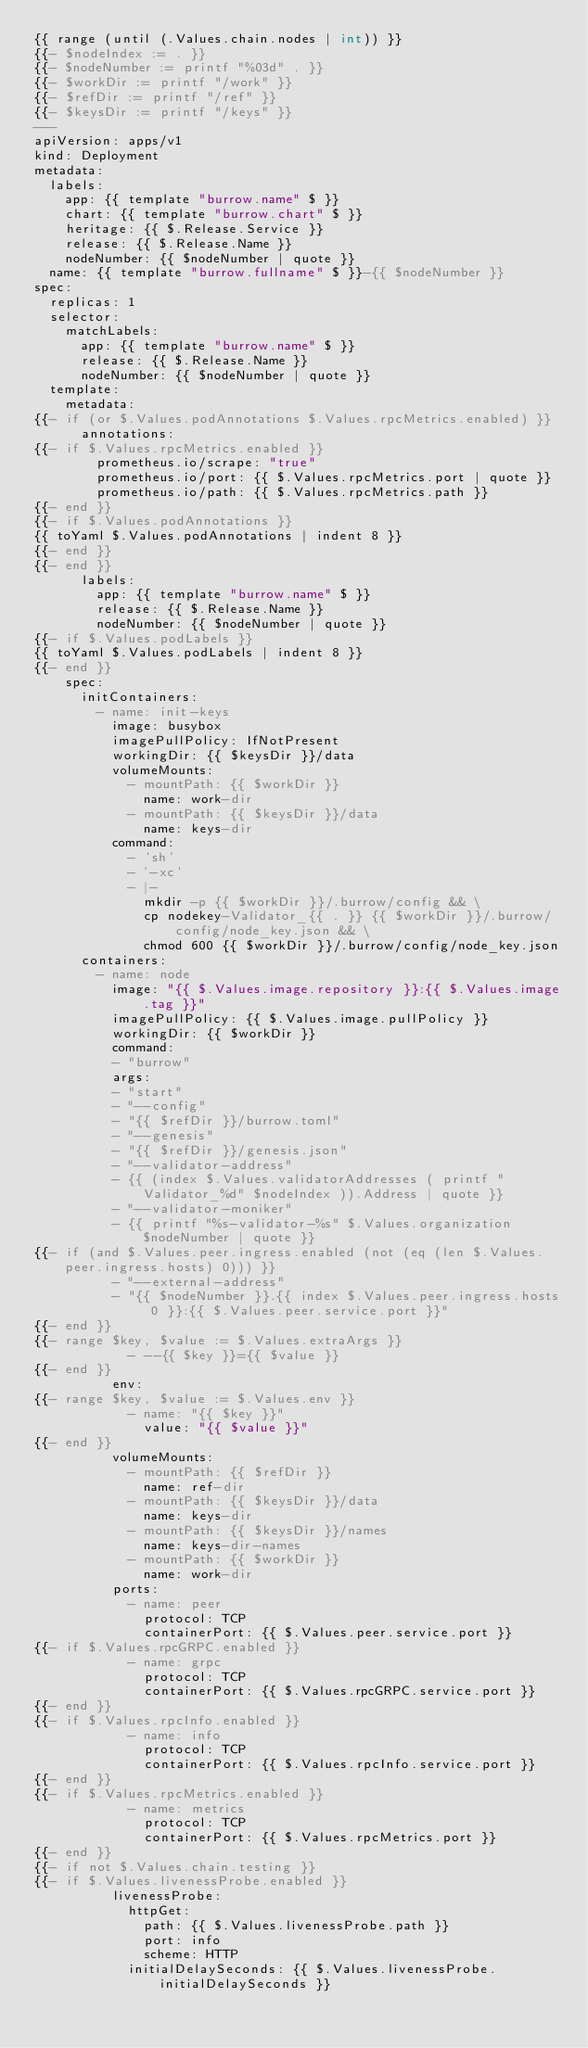<code> <loc_0><loc_0><loc_500><loc_500><_YAML_>{{ range (until (.Values.chain.nodes | int)) }}
{{- $nodeIndex := . }}
{{- $nodeNumber := printf "%03d" . }}
{{- $workDir := printf "/work" }}
{{- $refDir := printf "/ref" }}
{{- $keysDir := printf "/keys" }}
---
apiVersion: apps/v1
kind: Deployment
metadata:
  labels:
    app: {{ template "burrow.name" $ }}
    chart: {{ template "burrow.chart" $ }}
    heritage: {{ $.Release.Service }}
    release: {{ $.Release.Name }}
    nodeNumber: {{ $nodeNumber | quote }}
  name: {{ template "burrow.fullname" $ }}-{{ $nodeNumber }}
spec:
  replicas: 1
  selector:
    matchLabels:
      app: {{ template "burrow.name" $ }}
      release: {{ $.Release.Name }}
      nodeNumber: {{ $nodeNumber | quote }}
  template:
    metadata:
{{- if (or $.Values.podAnnotations $.Values.rpcMetrics.enabled) }}
      annotations:
{{- if $.Values.rpcMetrics.enabled }}
        prometheus.io/scrape: "true"
        prometheus.io/port: {{ $.Values.rpcMetrics.port | quote }}
        prometheus.io/path: {{ $.Values.rpcMetrics.path }}
{{- end }}
{{- if $.Values.podAnnotations }}
{{ toYaml $.Values.podAnnotations | indent 8 }}
{{- end }}
{{- end }}
      labels:
        app: {{ template "burrow.name" $ }}
        release: {{ $.Release.Name }}
        nodeNumber: {{ $nodeNumber | quote }}
{{- if $.Values.podLabels }}
{{ toYaml $.Values.podLabels | indent 8 }}
{{- end }}
    spec:
      initContainers:
        - name: init-keys
          image: busybox
          imagePullPolicy: IfNotPresent
          workingDir: {{ $keysDir }}/data
          volumeMounts:
            - mountPath: {{ $workDir }}
              name: work-dir
            - mountPath: {{ $keysDir }}/data
              name: keys-dir
          command:
            - 'sh'
            - '-xc'
            - |-
              mkdir -p {{ $workDir }}/.burrow/config && \
              cp nodekey-Validator_{{ . }} {{ $workDir }}/.burrow/config/node_key.json && \
              chmod 600 {{ $workDir }}/.burrow/config/node_key.json
      containers:
        - name: node
          image: "{{ $.Values.image.repository }}:{{ $.Values.image.tag }}"
          imagePullPolicy: {{ $.Values.image.pullPolicy }}
          workingDir: {{ $workDir }}
          command:
          - "burrow"
          args:
          - "start"
          - "--config"
          - "{{ $refDir }}/burrow.toml"
          - "--genesis"
          - "{{ $refDir }}/genesis.json"
          - "--validator-address"
          - {{ (index $.Values.validatorAddresses ( printf "Validator_%d" $nodeIndex )).Address | quote }}
          - "--validator-moniker"
          - {{ printf "%s-validator-%s" $.Values.organization $nodeNumber | quote }}
{{- if (and $.Values.peer.ingress.enabled (not (eq (len $.Values.peer.ingress.hosts) 0))) }}
          - "--external-address"
          - "{{ $nodeNumber }}.{{ index $.Values.peer.ingress.hosts 0 }}:{{ $.Values.peer.service.port }}"
{{- end }}
{{- range $key, $value := $.Values.extraArgs }}
            - --{{ $key }}={{ $value }}
{{- end }}
          env:
{{- range $key, $value := $.Values.env }}
            - name: "{{ $key }}"
              value: "{{ $value }}"
{{- end }}
          volumeMounts:
            - mountPath: {{ $refDir }}
              name: ref-dir
            - mountPath: {{ $keysDir }}/data
              name: keys-dir
            - mountPath: {{ $keysDir }}/names
              name: keys-dir-names
            - mountPath: {{ $workDir }}
              name: work-dir
          ports:
            - name: peer
              protocol: TCP
              containerPort: {{ $.Values.peer.service.port }}
{{- if $.Values.rpcGRPC.enabled }}
            - name: grpc
              protocol: TCP
              containerPort: {{ $.Values.rpcGRPC.service.port }}
{{- end }}
{{- if $.Values.rpcInfo.enabled }}
            - name: info
              protocol: TCP
              containerPort: {{ $.Values.rpcInfo.service.port }}
{{- end }}
{{- if $.Values.rpcMetrics.enabled }}
            - name: metrics
              protocol: TCP
              containerPort: {{ $.Values.rpcMetrics.port }}
{{- end }}
{{- if not $.Values.chain.testing }}
{{- if $.Values.livenessProbe.enabled }}
          livenessProbe:
            httpGet:
              path: {{ $.Values.livenessProbe.path }}
              port: info
              scheme: HTTP
            initialDelaySeconds: {{ $.Values.livenessProbe.initialDelaySeconds }}</code> 